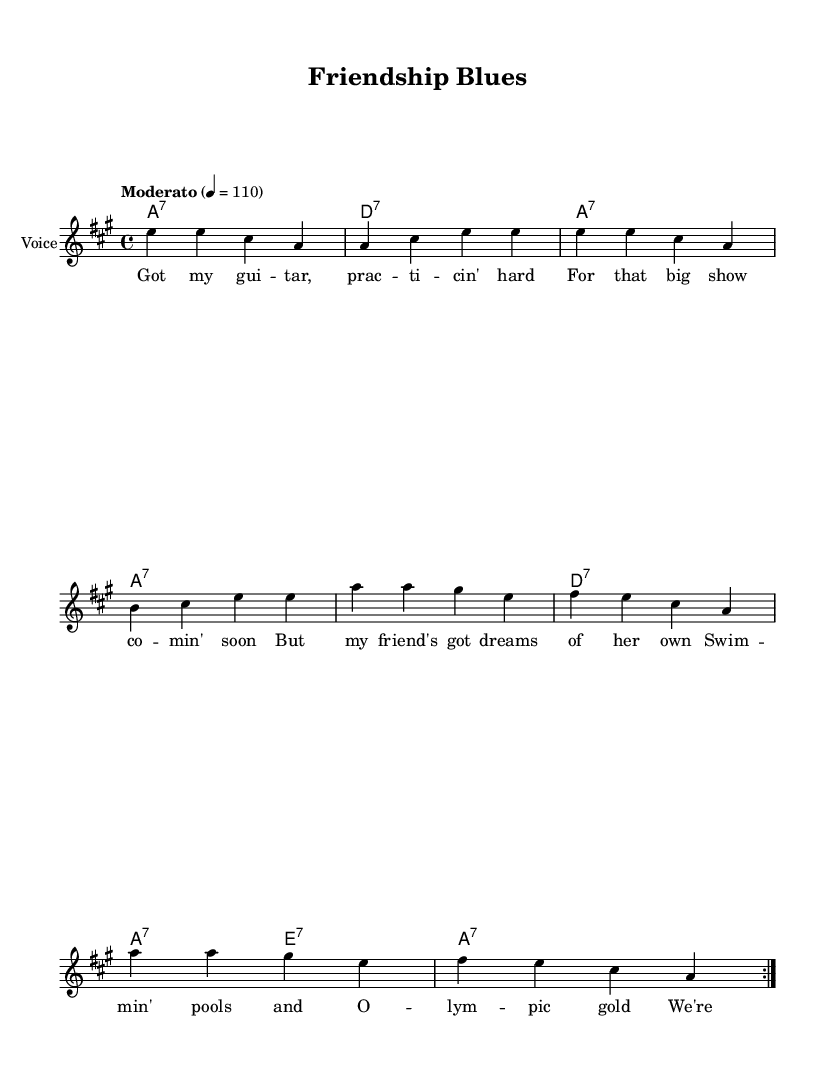What is the key signature of this music? The key signature is A major, which has three sharps (F#, C#, and G#). This identifies the tonal center of the piece as A.
Answer: A major What is the time signature of this music? The time signature is 4/4, indicating that there are four beats in each measure and the quarter note gets one beat. This is a common signature for many genres, including blues.
Answer: 4/4 What is the tempo marking given in the score? The tempo marking is "Moderato," which typically indicates a moderate pace, often around 100-112 beats per minute. It sets the speed for the performance of the piece.
Answer: Moderato How many times does the main melody repeat? The main melody repeats two times, as indicated by the "repeat volta 2" instruction before it. This ensures that the listener hears the primary theme multiple times.
Answer: 2 What type of chords are primarily used in the harmony section? The harmony section primarily features seventh chords, such as A7 and D7. These chords are typical in blues music to emphasize a richer harmonic texture and provide a characteristic sound.
Answer: Seventh chords What themes are present in the lyrics of this song? The lyrics highlight themes of personal ambition and friendship, illustrating the balance between pursuing one's own goals and supporting a friend's dreams, particularly in competitive environments like sports.
Answer: Personal ambition and friendship 